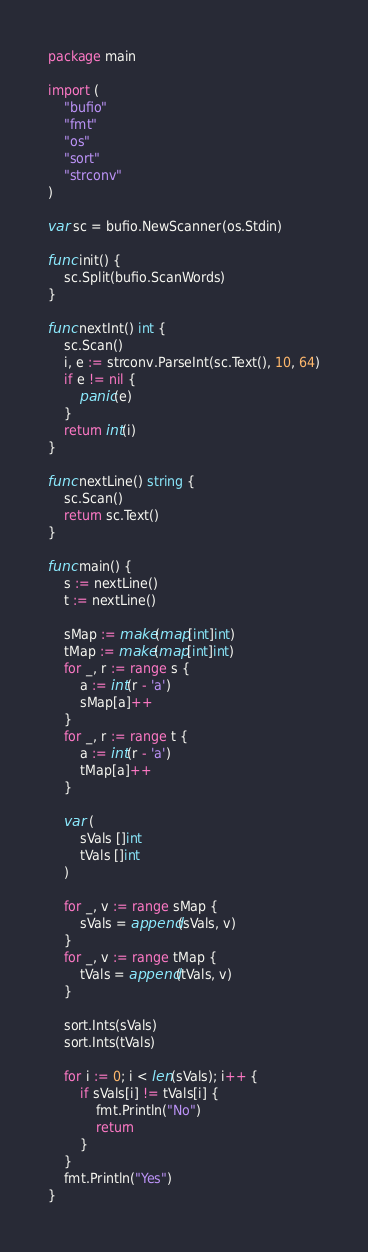Convert code to text. <code><loc_0><loc_0><loc_500><loc_500><_Go_>package main

import (
	"bufio"
	"fmt"
	"os"
	"sort"
	"strconv"
)

var sc = bufio.NewScanner(os.Stdin)

func init() {
	sc.Split(bufio.ScanWords)
}

func nextInt() int {
	sc.Scan()
	i, e := strconv.ParseInt(sc.Text(), 10, 64)
	if e != nil {
		panic(e)
	}
	return int(i)
}

func nextLine() string {
	sc.Scan()
	return sc.Text()
}

func main() {
	s := nextLine()
	t := nextLine()

	sMap := make(map[int]int)
	tMap := make(map[int]int)
	for _, r := range s {
		a := int(r - 'a')
		sMap[a]++
	}
	for _, r := range t {
		a := int(r - 'a')
		tMap[a]++
	}

	var (
		sVals []int
		tVals []int
	)

	for _, v := range sMap {
		sVals = append(sVals, v)
	}
	for _, v := range tMap {
		tVals = append(tVals, v)
	}

	sort.Ints(sVals)
	sort.Ints(tVals)

	for i := 0; i < len(sVals); i++ {
		if sVals[i] != tVals[i] {
			fmt.Println("No")
			return
		}
	}
	fmt.Println("Yes")
}
</code> 